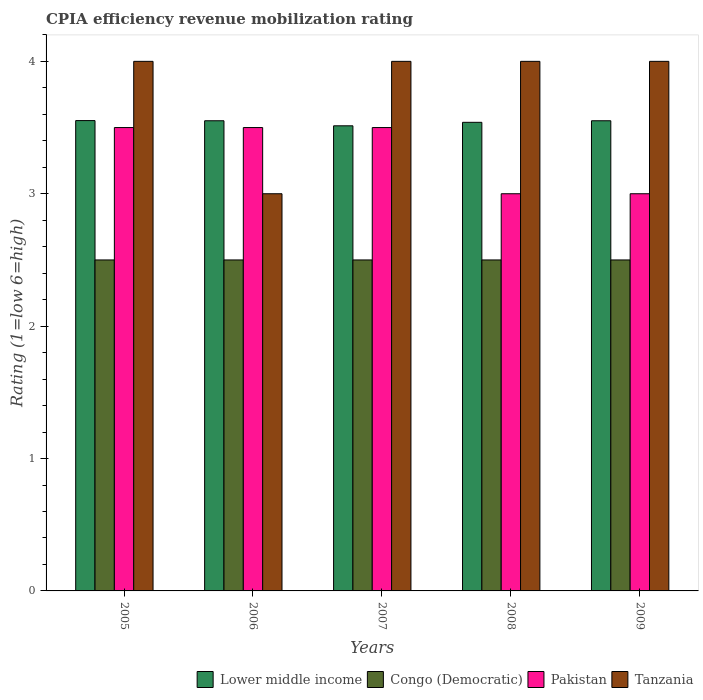How many different coloured bars are there?
Keep it short and to the point. 4. Are the number of bars per tick equal to the number of legend labels?
Provide a succinct answer. Yes. Are the number of bars on each tick of the X-axis equal?
Ensure brevity in your answer.  Yes. How many bars are there on the 4th tick from the right?
Offer a very short reply. 4. In how many cases, is the number of bars for a given year not equal to the number of legend labels?
Your answer should be compact. 0. In which year was the CPIA rating in Tanzania maximum?
Give a very brief answer. 2005. What is the total CPIA rating in Tanzania in the graph?
Give a very brief answer. 19. What is the difference between the CPIA rating in Pakistan in 2006 and that in 2009?
Your answer should be compact. 0.5. What is the difference between the CPIA rating in Lower middle income in 2007 and the CPIA rating in Pakistan in 2008?
Provide a succinct answer. 0.51. What is the average CPIA rating in Lower middle income per year?
Your answer should be compact. 3.54. In the year 2008, what is the difference between the CPIA rating in Congo (Democratic) and CPIA rating in Lower middle income?
Your answer should be very brief. -1.04. In how many years, is the CPIA rating in Pakistan greater than 3.4?
Offer a very short reply. 3. What is the ratio of the CPIA rating in Tanzania in 2007 to that in 2008?
Make the answer very short. 1. What is the difference between the highest and the lowest CPIA rating in Lower middle income?
Offer a very short reply. 0.04. Is the sum of the CPIA rating in Lower middle income in 2008 and 2009 greater than the maximum CPIA rating in Congo (Democratic) across all years?
Keep it short and to the point. Yes. What does the 4th bar from the left in 2006 represents?
Provide a short and direct response. Tanzania. What does the 3rd bar from the right in 2007 represents?
Offer a terse response. Congo (Democratic). Is it the case that in every year, the sum of the CPIA rating in Lower middle income and CPIA rating in Congo (Democratic) is greater than the CPIA rating in Pakistan?
Ensure brevity in your answer.  Yes. Are all the bars in the graph horizontal?
Offer a very short reply. No. Does the graph contain any zero values?
Give a very brief answer. No. Does the graph contain grids?
Offer a terse response. No. Where does the legend appear in the graph?
Ensure brevity in your answer.  Bottom right. What is the title of the graph?
Ensure brevity in your answer.  CPIA efficiency revenue mobilization rating. Does "Canada" appear as one of the legend labels in the graph?
Provide a short and direct response. No. What is the label or title of the Y-axis?
Ensure brevity in your answer.  Rating (1=low 6=high). What is the Rating (1=low 6=high) of Lower middle income in 2005?
Your response must be concise. 3.55. What is the Rating (1=low 6=high) in Congo (Democratic) in 2005?
Make the answer very short. 2.5. What is the Rating (1=low 6=high) of Tanzania in 2005?
Offer a very short reply. 4. What is the Rating (1=low 6=high) of Lower middle income in 2006?
Your answer should be compact. 3.55. What is the Rating (1=low 6=high) in Pakistan in 2006?
Ensure brevity in your answer.  3.5. What is the Rating (1=low 6=high) in Tanzania in 2006?
Provide a succinct answer. 3. What is the Rating (1=low 6=high) in Lower middle income in 2007?
Offer a terse response. 3.51. What is the Rating (1=low 6=high) in Tanzania in 2007?
Ensure brevity in your answer.  4. What is the Rating (1=low 6=high) in Lower middle income in 2008?
Give a very brief answer. 3.54. What is the Rating (1=low 6=high) in Tanzania in 2008?
Offer a terse response. 4. What is the Rating (1=low 6=high) of Lower middle income in 2009?
Your response must be concise. 3.55. What is the Rating (1=low 6=high) in Congo (Democratic) in 2009?
Your response must be concise. 2.5. What is the Rating (1=low 6=high) of Pakistan in 2009?
Your answer should be very brief. 3. Across all years, what is the maximum Rating (1=low 6=high) in Lower middle income?
Ensure brevity in your answer.  3.55. Across all years, what is the minimum Rating (1=low 6=high) in Lower middle income?
Offer a very short reply. 3.51. Across all years, what is the minimum Rating (1=low 6=high) in Congo (Democratic)?
Provide a short and direct response. 2.5. Across all years, what is the minimum Rating (1=low 6=high) in Tanzania?
Provide a succinct answer. 3. What is the total Rating (1=low 6=high) in Lower middle income in the graph?
Make the answer very short. 17.71. What is the total Rating (1=low 6=high) in Congo (Democratic) in the graph?
Your answer should be compact. 12.5. What is the total Rating (1=low 6=high) of Tanzania in the graph?
Provide a short and direct response. 19. What is the difference between the Rating (1=low 6=high) of Lower middle income in 2005 and that in 2006?
Your response must be concise. 0. What is the difference between the Rating (1=low 6=high) in Congo (Democratic) in 2005 and that in 2006?
Keep it short and to the point. 0. What is the difference between the Rating (1=low 6=high) of Pakistan in 2005 and that in 2006?
Provide a short and direct response. 0. What is the difference between the Rating (1=low 6=high) in Tanzania in 2005 and that in 2006?
Offer a terse response. 1. What is the difference between the Rating (1=low 6=high) of Lower middle income in 2005 and that in 2007?
Give a very brief answer. 0.04. What is the difference between the Rating (1=low 6=high) in Pakistan in 2005 and that in 2007?
Your answer should be very brief. 0. What is the difference between the Rating (1=low 6=high) of Tanzania in 2005 and that in 2007?
Make the answer very short. 0. What is the difference between the Rating (1=low 6=high) of Lower middle income in 2005 and that in 2008?
Offer a very short reply. 0.01. What is the difference between the Rating (1=low 6=high) in Pakistan in 2005 and that in 2008?
Provide a succinct answer. 0.5. What is the difference between the Rating (1=low 6=high) in Tanzania in 2005 and that in 2008?
Offer a very short reply. 0. What is the difference between the Rating (1=low 6=high) in Lower middle income in 2005 and that in 2009?
Your answer should be compact. 0. What is the difference between the Rating (1=low 6=high) of Congo (Democratic) in 2005 and that in 2009?
Keep it short and to the point. 0. What is the difference between the Rating (1=low 6=high) of Tanzania in 2005 and that in 2009?
Your answer should be compact. 0. What is the difference between the Rating (1=low 6=high) of Lower middle income in 2006 and that in 2007?
Ensure brevity in your answer.  0.04. What is the difference between the Rating (1=low 6=high) of Lower middle income in 2006 and that in 2008?
Your answer should be compact. 0.01. What is the difference between the Rating (1=low 6=high) of Congo (Democratic) in 2006 and that in 2008?
Keep it short and to the point. 0. What is the difference between the Rating (1=low 6=high) in Pakistan in 2006 and that in 2008?
Ensure brevity in your answer.  0.5. What is the difference between the Rating (1=low 6=high) in Tanzania in 2006 and that in 2008?
Provide a short and direct response. -1. What is the difference between the Rating (1=low 6=high) in Congo (Democratic) in 2006 and that in 2009?
Offer a very short reply. 0. What is the difference between the Rating (1=low 6=high) of Pakistan in 2006 and that in 2009?
Your response must be concise. 0.5. What is the difference between the Rating (1=low 6=high) in Lower middle income in 2007 and that in 2008?
Give a very brief answer. -0.03. What is the difference between the Rating (1=low 6=high) in Congo (Democratic) in 2007 and that in 2008?
Provide a short and direct response. 0. What is the difference between the Rating (1=low 6=high) in Pakistan in 2007 and that in 2008?
Make the answer very short. 0.5. What is the difference between the Rating (1=low 6=high) of Tanzania in 2007 and that in 2008?
Provide a succinct answer. 0. What is the difference between the Rating (1=low 6=high) of Lower middle income in 2007 and that in 2009?
Provide a succinct answer. -0.04. What is the difference between the Rating (1=low 6=high) in Congo (Democratic) in 2007 and that in 2009?
Your response must be concise. 0. What is the difference between the Rating (1=low 6=high) of Lower middle income in 2008 and that in 2009?
Provide a succinct answer. -0.01. What is the difference between the Rating (1=low 6=high) of Congo (Democratic) in 2008 and that in 2009?
Your answer should be compact. 0. What is the difference between the Rating (1=low 6=high) of Pakistan in 2008 and that in 2009?
Offer a very short reply. 0. What is the difference between the Rating (1=low 6=high) of Tanzania in 2008 and that in 2009?
Offer a terse response. 0. What is the difference between the Rating (1=low 6=high) of Lower middle income in 2005 and the Rating (1=low 6=high) of Congo (Democratic) in 2006?
Provide a succinct answer. 1.05. What is the difference between the Rating (1=low 6=high) of Lower middle income in 2005 and the Rating (1=low 6=high) of Pakistan in 2006?
Provide a succinct answer. 0.05. What is the difference between the Rating (1=low 6=high) in Lower middle income in 2005 and the Rating (1=low 6=high) in Tanzania in 2006?
Offer a very short reply. 0.55. What is the difference between the Rating (1=low 6=high) in Congo (Democratic) in 2005 and the Rating (1=low 6=high) in Pakistan in 2006?
Make the answer very short. -1. What is the difference between the Rating (1=low 6=high) in Pakistan in 2005 and the Rating (1=low 6=high) in Tanzania in 2006?
Offer a terse response. 0.5. What is the difference between the Rating (1=low 6=high) in Lower middle income in 2005 and the Rating (1=low 6=high) in Congo (Democratic) in 2007?
Offer a very short reply. 1.05. What is the difference between the Rating (1=low 6=high) of Lower middle income in 2005 and the Rating (1=low 6=high) of Pakistan in 2007?
Make the answer very short. 0.05. What is the difference between the Rating (1=low 6=high) of Lower middle income in 2005 and the Rating (1=low 6=high) of Tanzania in 2007?
Provide a succinct answer. -0.45. What is the difference between the Rating (1=low 6=high) of Lower middle income in 2005 and the Rating (1=low 6=high) of Congo (Democratic) in 2008?
Your answer should be very brief. 1.05. What is the difference between the Rating (1=low 6=high) of Lower middle income in 2005 and the Rating (1=low 6=high) of Pakistan in 2008?
Offer a terse response. 0.55. What is the difference between the Rating (1=low 6=high) of Lower middle income in 2005 and the Rating (1=low 6=high) of Tanzania in 2008?
Your response must be concise. -0.45. What is the difference between the Rating (1=low 6=high) of Congo (Democratic) in 2005 and the Rating (1=low 6=high) of Pakistan in 2008?
Keep it short and to the point. -0.5. What is the difference between the Rating (1=low 6=high) in Congo (Democratic) in 2005 and the Rating (1=low 6=high) in Tanzania in 2008?
Keep it short and to the point. -1.5. What is the difference between the Rating (1=low 6=high) in Pakistan in 2005 and the Rating (1=low 6=high) in Tanzania in 2008?
Give a very brief answer. -0.5. What is the difference between the Rating (1=low 6=high) of Lower middle income in 2005 and the Rating (1=low 6=high) of Congo (Democratic) in 2009?
Provide a succinct answer. 1.05. What is the difference between the Rating (1=low 6=high) in Lower middle income in 2005 and the Rating (1=low 6=high) in Pakistan in 2009?
Provide a short and direct response. 0.55. What is the difference between the Rating (1=low 6=high) in Lower middle income in 2005 and the Rating (1=low 6=high) in Tanzania in 2009?
Offer a very short reply. -0.45. What is the difference between the Rating (1=low 6=high) of Congo (Democratic) in 2005 and the Rating (1=low 6=high) of Pakistan in 2009?
Offer a terse response. -0.5. What is the difference between the Rating (1=low 6=high) of Pakistan in 2005 and the Rating (1=low 6=high) of Tanzania in 2009?
Your answer should be very brief. -0.5. What is the difference between the Rating (1=low 6=high) of Lower middle income in 2006 and the Rating (1=low 6=high) of Congo (Democratic) in 2007?
Offer a terse response. 1.05. What is the difference between the Rating (1=low 6=high) in Lower middle income in 2006 and the Rating (1=low 6=high) in Pakistan in 2007?
Ensure brevity in your answer.  0.05. What is the difference between the Rating (1=low 6=high) in Lower middle income in 2006 and the Rating (1=low 6=high) in Tanzania in 2007?
Your response must be concise. -0.45. What is the difference between the Rating (1=low 6=high) of Lower middle income in 2006 and the Rating (1=low 6=high) of Congo (Democratic) in 2008?
Your response must be concise. 1.05. What is the difference between the Rating (1=low 6=high) of Lower middle income in 2006 and the Rating (1=low 6=high) of Pakistan in 2008?
Your answer should be compact. 0.55. What is the difference between the Rating (1=low 6=high) in Lower middle income in 2006 and the Rating (1=low 6=high) in Tanzania in 2008?
Ensure brevity in your answer.  -0.45. What is the difference between the Rating (1=low 6=high) in Congo (Democratic) in 2006 and the Rating (1=low 6=high) in Pakistan in 2008?
Offer a very short reply. -0.5. What is the difference between the Rating (1=low 6=high) in Congo (Democratic) in 2006 and the Rating (1=low 6=high) in Tanzania in 2008?
Make the answer very short. -1.5. What is the difference between the Rating (1=low 6=high) in Pakistan in 2006 and the Rating (1=low 6=high) in Tanzania in 2008?
Offer a terse response. -0.5. What is the difference between the Rating (1=low 6=high) of Lower middle income in 2006 and the Rating (1=low 6=high) of Congo (Democratic) in 2009?
Give a very brief answer. 1.05. What is the difference between the Rating (1=low 6=high) in Lower middle income in 2006 and the Rating (1=low 6=high) in Pakistan in 2009?
Offer a terse response. 0.55. What is the difference between the Rating (1=low 6=high) of Lower middle income in 2006 and the Rating (1=low 6=high) of Tanzania in 2009?
Offer a terse response. -0.45. What is the difference between the Rating (1=low 6=high) in Pakistan in 2006 and the Rating (1=low 6=high) in Tanzania in 2009?
Make the answer very short. -0.5. What is the difference between the Rating (1=low 6=high) of Lower middle income in 2007 and the Rating (1=low 6=high) of Congo (Democratic) in 2008?
Your answer should be very brief. 1.01. What is the difference between the Rating (1=low 6=high) in Lower middle income in 2007 and the Rating (1=low 6=high) in Pakistan in 2008?
Provide a short and direct response. 0.51. What is the difference between the Rating (1=low 6=high) of Lower middle income in 2007 and the Rating (1=low 6=high) of Tanzania in 2008?
Keep it short and to the point. -0.49. What is the difference between the Rating (1=low 6=high) in Congo (Democratic) in 2007 and the Rating (1=low 6=high) in Pakistan in 2008?
Make the answer very short. -0.5. What is the difference between the Rating (1=low 6=high) in Pakistan in 2007 and the Rating (1=low 6=high) in Tanzania in 2008?
Keep it short and to the point. -0.5. What is the difference between the Rating (1=low 6=high) in Lower middle income in 2007 and the Rating (1=low 6=high) in Congo (Democratic) in 2009?
Offer a very short reply. 1.01. What is the difference between the Rating (1=low 6=high) of Lower middle income in 2007 and the Rating (1=low 6=high) of Pakistan in 2009?
Your answer should be compact. 0.51. What is the difference between the Rating (1=low 6=high) of Lower middle income in 2007 and the Rating (1=low 6=high) of Tanzania in 2009?
Your answer should be very brief. -0.49. What is the difference between the Rating (1=low 6=high) in Congo (Democratic) in 2007 and the Rating (1=low 6=high) in Pakistan in 2009?
Your answer should be compact. -0.5. What is the difference between the Rating (1=low 6=high) of Congo (Democratic) in 2007 and the Rating (1=low 6=high) of Tanzania in 2009?
Keep it short and to the point. -1.5. What is the difference between the Rating (1=low 6=high) in Pakistan in 2007 and the Rating (1=low 6=high) in Tanzania in 2009?
Your response must be concise. -0.5. What is the difference between the Rating (1=low 6=high) in Lower middle income in 2008 and the Rating (1=low 6=high) in Congo (Democratic) in 2009?
Give a very brief answer. 1.04. What is the difference between the Rating (1=low 6=high) in Lower middle income in 2008 and the Rating (1=low 6=high) in Pakistan in 2009?
Provide a succinct answer. 0.54. What is the difference between the Rating (1=low 6=high) in Lower middle income in 2008 and the Rating (1=low 6=high) in Tanzania in 2009?
Ensure brevity in your answer.  -0.46. What is the difference between the Rating (1=low 6=high) in Congo (Democratic) in 2008 and the Rating (1=low 6=high) in Tanzania in 2009?
Your answer should be compact. -1.5. What is the average Rating (1=low 6=high) of Lower middle income per year?
Your answer should be very brief. 3.54. What is the average Rating (1=low 6=high) in Congo (Democratic) per year?
Your answer should be very brief. 2.5. What is the average Rating (1=low 6=high) in Pakistan per year?
Offer a very short reply. 3.3. In the year 2005, what is the difference between the Rating (1=low 6=high) of Lower middle income and Rating (1=low 6=high) of Congo (Democratic)?
Provide a succinct answer. 1.05. In the year 2005, what is the difference between the Rating (1=low 6=high) of Lower middle income and Rating (1=low 6=high) of Pakistan?
Your answer should be compact. 0.05. In the year 2005, what is the difference between the Rating (1=low 6=high) in Lower middle income and Rating (1=low 6=high) in Tanzania?
Offer a terse response. -0.45. In the year 2005, what is the difference between the Rating (1=low 6=high) of Congo (Democratic) and Rating (1=low 6=high) of Pakistan?
Offer a terse response. -1. In the year 2006, what is the difference between the Rating (1=low 6=high) of Lower middle income and Rating (1=low 6=high) of Congo (Democratic)?
Ensure brevity in your answer.  1.05. In the year 2006, what is the difference between the Rating (1=low 6=high) of Lower middle income and Rating (1=low 6=high) of Pakistan?
Offer a very short reply. 0.05. In the year 2006, what is the difference between the Rating (1=low 6=high) of Lower middle income and Rating (1=low 6=high) of Tanzania?
Make the answer very short. 0.55. In the year 2006, what is the difference between the Rating (1=low 6=high) in Congo (Democratic) and Rating (1=low 6=high) in Pakistan?
Provide a short and direct response. -1. In the year 2006, what is the difference between the Rating (1=low 6=high) in Congo (Democratic) and Rating (1=low 6=high) in Tanzania?
Your answer should be very brief. -0.5. In the year 2006, what is the difference between the Rating (1=low 6=high) in Pakistan and Rating (1=low 6=high) in Tanzania?
Offer a very short reply. 0.5. In the year 2007, what is the difference between the Rating (1=low 6=high) in Lower middle income and Rating (1=low 6=high) in Congo (Democratic)?
Give a very brief answer. 1.01. In the year 2007, what is the difference between the Rating (1=low 6=high) in Lower middle income and Rating (1=low 6=high) in Pakistan?
Offer a very short reply. 0.01. In the year 2007, what is the difference between the Rating (1=low 6=high) of Lower middle income and Rating (1=low 6=high) of Tanzania?
Keep it short and to the point. -0.49. In the year 2007, what is the difference between the Rating (1=low 6=high) of Congo (Democratic) and Rating (1=low 6=high) of Pakistan?
Provide a succinct answer. -1. In the year 2007, what is the difference between the Rating (1=low 6=high) of Pakistan and Rating (1=low 6=high) of Tanzania?
Make the answer very short. -0.5. In the year 2008, what is the difference between the Rating (1=low 6=high) of Lower middle income and Rating (1=low 6=high) of Congo (Democratic)?
Your response must be concise. 1.04. In the year 2008, what is the difference between the Rating (1=low 6=high) in Lower middle income and Rating (1=low 6=high) in Pakistan?
Keep it short and to the point. 0.54. In the year 2008, what is the difference between the Rating (1=low 6=high) of Lower middle income and Rating (1=low 6=high) of Tanzania?
Your answer should be compact. -0.46. In the year 2008, what is the difference between the Rating (1=low 6=high) of Congo (Democratic) and Rating (1=low 6=high) of Pakistan?
Your answer should be compact. -0.5. In the year 2009, what is the difference between the Rating (1=low 6=high) in Lower middle income and Rating (1=low 6=high) in Congo (Democratic)?
Make the answer very short. 1.05. In the year 2009, what is the difference between the Rating (1=low 6=high) of Lower middle income and Rating (1=low 6=high) of Pakistan?
Your answer should be compact. 0.55. In the year 2009, what is the difference between the Rating (1=low 6=high) in Lower middle income and Rating (1=low 6=high) in Tanzania?
Offer a terse response. -0.45. In the year 2009, what is the difference between the Rating (1=low 6=high) in Congo (Democratic) and Rating (1=low 6=high) in Tanzania?
Your response must be concise. -1.5. In the year 2009, what is the difference between the Rating (1=low 6=high) of Pakistan and Rating (1=low 6=high) of Tanzania?
Give a very brief answer. -1. What is the ratio of the Rating (1=low 6=high) in Congo (Democratic) in 2005 to that in 2006?
Your answer should be compact. 1. What is the ratio of the Rating (1=low 6=high) in Lower middle income in 2005 to that in 2007?
Provide a short and direct response. 1.01. What is the ratio of the Rating (1=low 6=high) in Pakistan in 2005 to that in 2007?
Offer a very short reply. 1. What is the ratio of the Rating (1=low 6=high) of Lower middle income in 2005 to that in 2008?
Your answer should be compact. 1. What is the ratio of the Rating (1=low 6=high) in Congo (Democratic) in 2005 to that in 2008?
Offer a terse response. 1. What is the ratio of the Rating (1=low 6=high) in Pakistan in 2005 to that in 2008?
Provide a succinct answer. 1.17. What is the ratio of the Rating (1=low 6=high) in Tanzania in 2005 to that in 2008?
Provide a short and direct response. 1. What is the ratio of the Rating (1=low 6=high) of Lower middle income in 2005 to that in 2009?
Give a very brief answer. 1. What is the ratio of the Rating (1=low 6=high) in Tanzania in 2005 to that in 2009?
Ensure brevity in your answer.  1. What is the ratio of the Rating (1=low 6=high) of Lower middle income in 2006 to that in 2007?
Keep it short and to the point. 1.01. What is the ratio of the Rating (1=low 6=high) of Congo (Democratic) in 2006 to that in 2007?
Provide a succinct answer. 1. What is the ratio of the Rating (1=low 6=high) of Pakistan in 2006 to that in 2007?
Your answer should be very brief. 1. What is the ratio of the Rating (1=low 6=high) in Lower middle income in 2006 to that in 2008?
Your response must be concise. 1. What is the ratio of the Rating (1=low 6=high) of Congo (Democratic) in 2006 to that in 2008?
Give a very brief answer. 1. What is the ratio of the Rating (1=low 6=high) in Tanzania in 2006 to that in 2008?
Your answer should be compact. 0.75. What is the ratio of the Rating (1=low 6=high) of Pakistan in 2006 to that in 2009?
Offer a terse response. 1.17. What is the ratio of the Rating (1=low 6=high) of Tanzania in 2006 to that in 2009?
Offer a very short reply. 0.75. What is the ratio of the Rating (1=low 6=high) of Congo (Democratic) in 2007 to that in 2008?
Your response must be concise. 1. What is the ratio of the Rating (1=low 6=high) in Pakistan in 2007 to that in 2008?
Your answer should be very brief. 1.17. What is the ratio of the Rating (1=low 6=high) in Tanzania in 2007 to that in 2008?
Give a very brief answer. 1. What is the ratio of the Rating (1=low 6=high) in Lower middle income in 2007 to that in 2009?
Your answer should be compact. 0.99. What is the ratio of the Rating (1=low 6=high) in Congo (Democratic) in 2007 to that in 2009?
Provide a short and direct response. 1. What is the ratio of the Rating (1=low 6=high) in Pakistan in 2007 to that in 2009?
Offer a very short reply. 1.17. What is the ratio of the Rating (1=low 6=high) in Tanzania in 2007 to that in 2009?
Ensure brevity in your answer.  1. What is the ratio of the Rating (1=low 6=high) in Lower middle income in 2008 to that in 2009?
Offer a very short reply. 1. What is the ratio of the Rating (1=low 6=high) in Congo (Democratic) in 2008 to that in 2009?
Your answer should be compact. 1. What is the ratio of the Rating (1=low 6=high) in Pakistan in 2008 to that in 2009?
Your answer should be very brief. 1. What is the ratio of the Rating (1=low 6=high) of Tanzania in 2008 to that in 2009?
Ensure brevity in your answer.  1. What is the difference between the highest and the second highest Rating (1=low 6=high) in Lower middle income?
Keep it short and to the point. 0. What is the difference between the highest and the lowest Rating (1=low 6=high) of Lower middle income?
Provide a short and direct response. 0.04. What is the difference between the highest and the lowest Rating (1=low 6=high) in Congo (Democratic)?
Ensure brevity in your answer.  0. What is the difference between the highest and the lowest Rating (1=low 6=high) of Pakistan?
Your answer should be very brief. 0.5. 